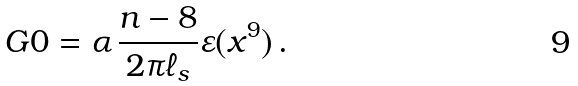<formula> <loc_0><loc_0><loc_500><loc_500>\ G { 0 } = \alpha \, \frac { n - 8 } { 2 \pi \ell _ { s } } \varepsilon ( x ^ { 9 } ) \, .</formula> 